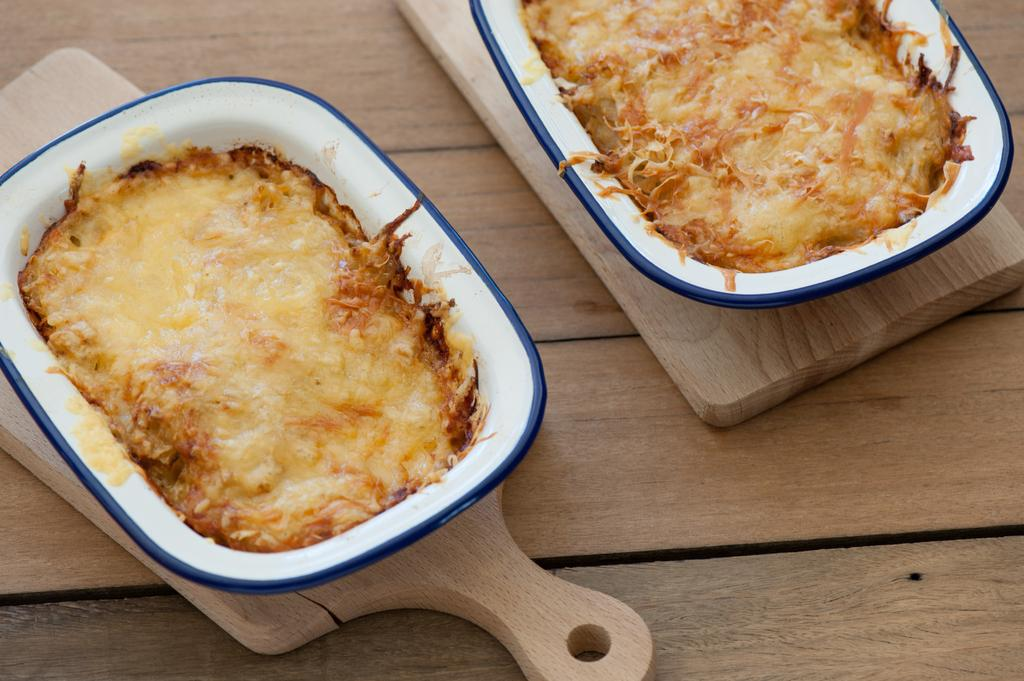What type of containers are holding the food items in the image? There are bowls holding the food items in the image. What material is the surface on which the bowls are placed? The wooden surface is present in the image. How many bunny legs can be seen in the image? There are no bunny legs present in the image. What type of bears are interacting with the food items in the image? There are no bears present in the image. 